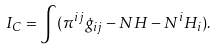Convert formula to latex. <formula><loc_0><loc_0><loc_500><loc_500>I _ { C } = \int ( \pi ^ { i j } \dot { g } _ { i j } - N H - N ^ { i } H _ { i } ) .</formula> 